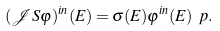Convert formula to latex. <formula><loc_0><loc_0><loc_500><loc_500>( \mathcal { J } S \varphi ) ^ { i n } ( E ) = \sigma ( E ) \varphi ^ { i n } ( E ) \ p .</formula> 